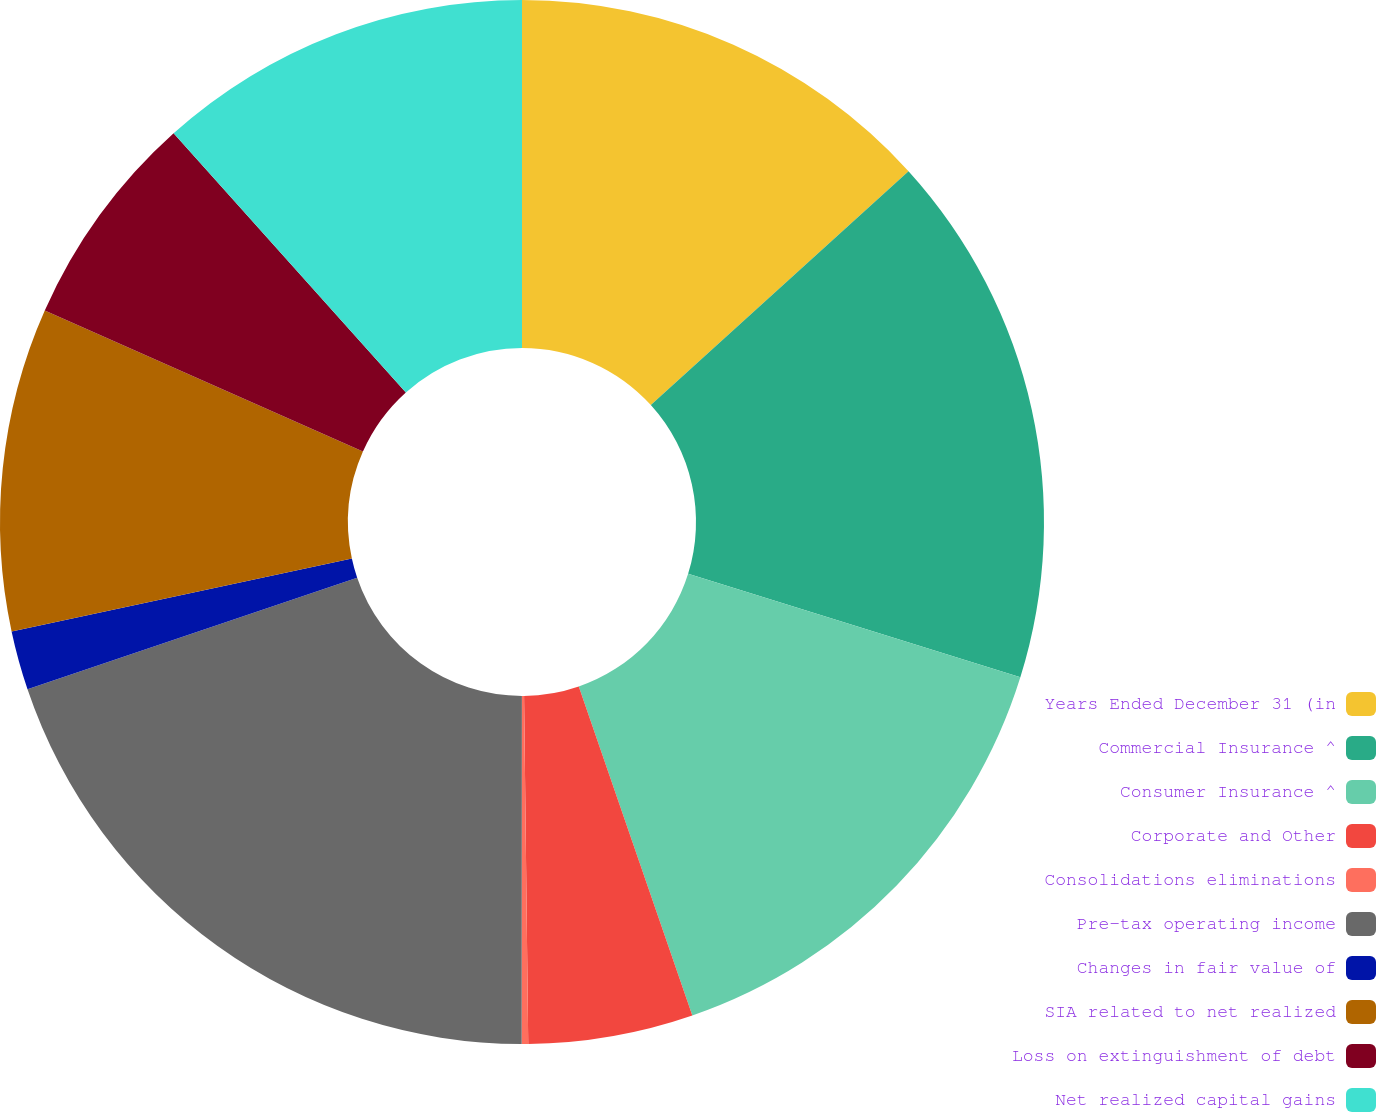Convert chart. <chart><loc_0><loc_0><loc_500><loc_500><pie_chart><fcel>Years Ended December 31 (in<fcel>Commercial Insurance ^<fcel>Consumer Insurance ^<fcel>Corporate and Other<fcel>Consolidations eliminations<fcel>Pre-tax operating income<fcel>Changes in fair value of<fcel>SIA related to net realized<fcel>Loss on extinguishment of debt<fcel>Net realized capital gains<nl><fcel>13.27%<fcel>16.54%<fcel>14.9%<fcel>5.1%<fcel>0.2%<fcel>19.8%<fcel>1.83%<fcel>10.0%<fcel>6.73%<fcel>11.63%<nl></chart> 